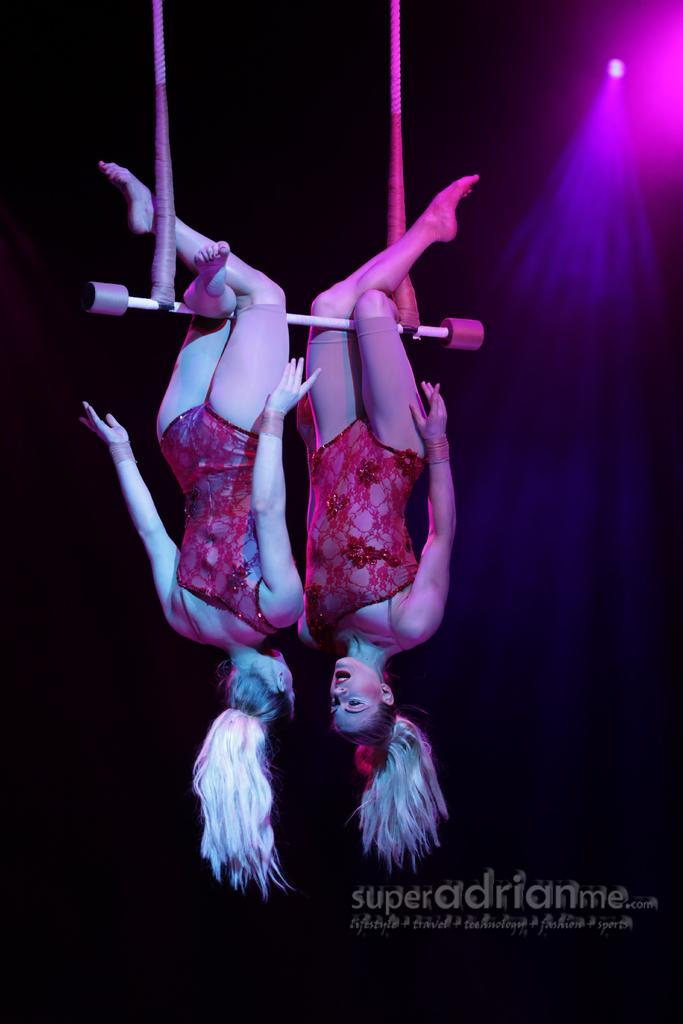What are the two women in the image doing? The two women are performing an aerial dance in the image. Can you describe any other elements in the image besides the women? Yes, there is some text visible in the image, and there is a light at the top right corner of the image. How fast are the women running in the image? The women are not running in the image; they are performing an aerial dance. What type of cannon is present in the image? There is no cannon present in the image. 